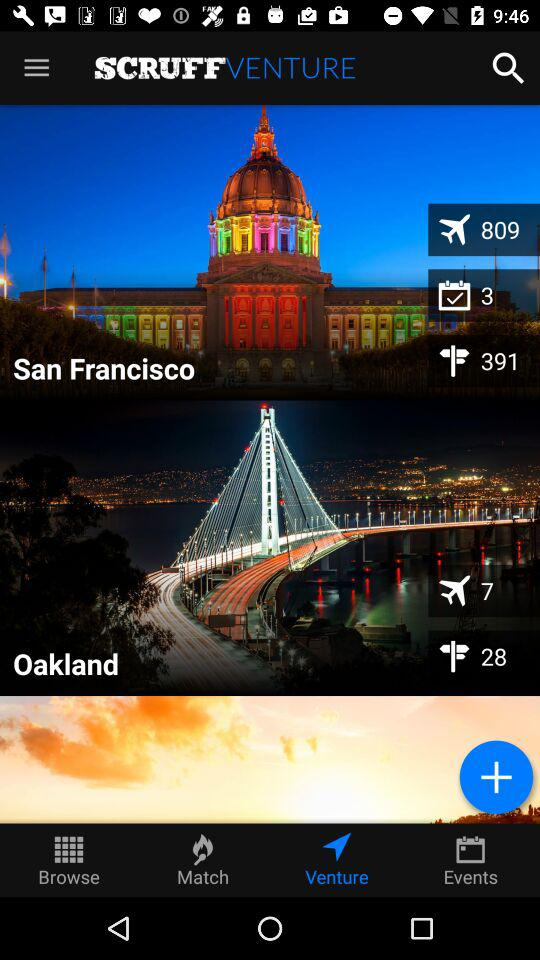Which tab has been selected? The tab "Venture" has been selected. 